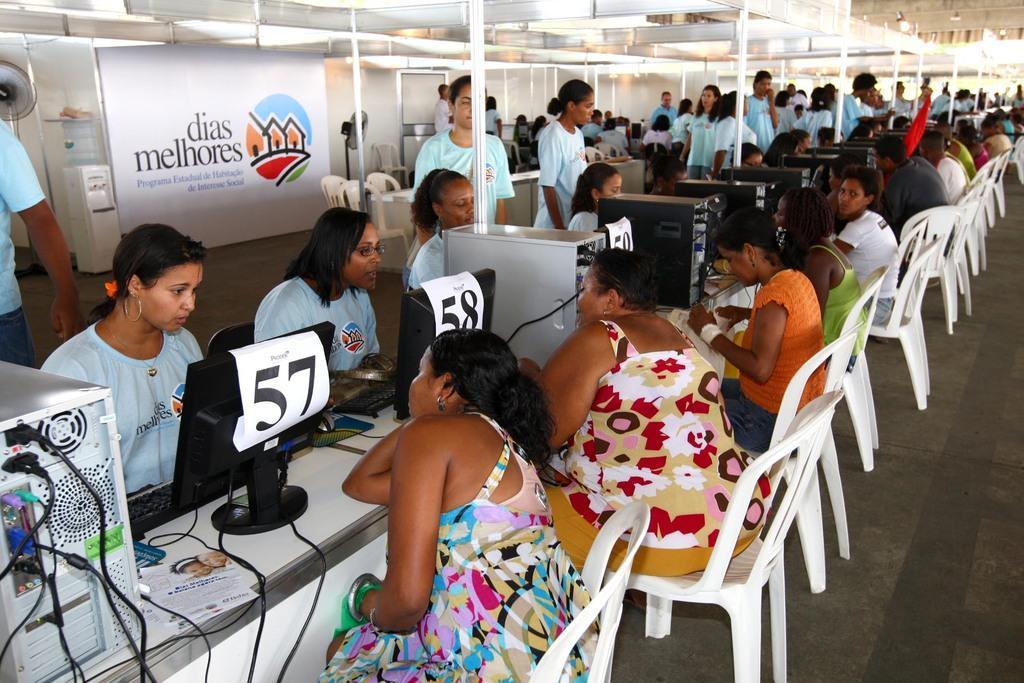Describe this image in one or two sentences. In this picture on the table there are monitors, CPU and papers on it. Out side of table there are many people sitting on the white chair. And inside the table there are few people with blue t-shirt some are sitting and some are standing. In the background there is a poster. On the top there is a tent. 